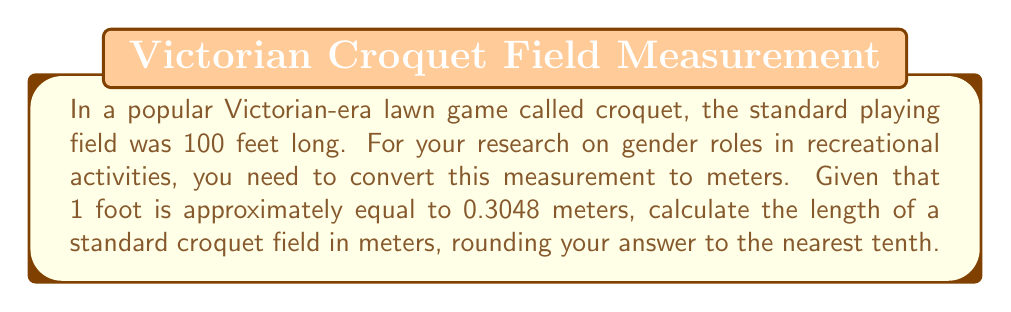Could you help me with this problem? To convert the length of the croquet field from feet to meters, we'll follow these steps:

1. Set up the conversion formula:
   $$ \text{Length in meters} = \text{Length in feet} \times \text{Conversion factor} $$

2. Substitute the known values:
   $$ \text{Length in meters} = 100 \text{ feet} \times 0.3048 \text{ meters/foot} $$

3. Perform the multiplication:
   $$ \text{Length in meters} = 30.48 \text{ meters} $$

4. Round the result to the nearest tenth:
   $$ 30.48 \text{ meters} \approx 30.5 \text{ meters} $$

Therefore, a standard Victorian-era croquet field of 100 feet is approximately 30.5 meters long.
Answer: 30.5 meters 